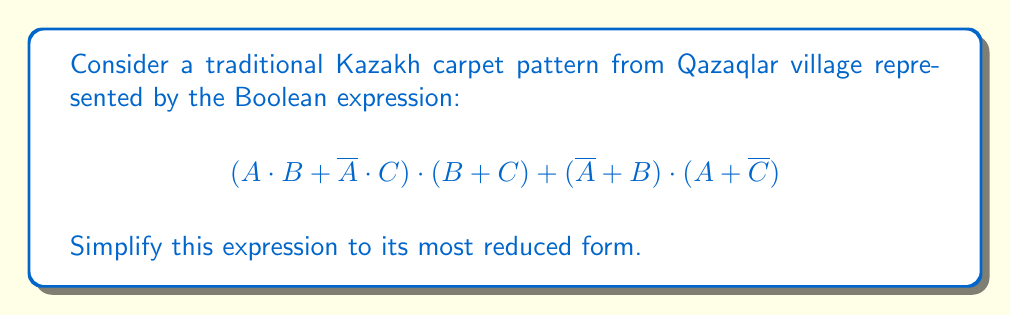Help me with this question. Let's simplify this expression step by step:

1) First, let's distribute the first term:
   $$(A \cdot B + \overline{A} \cdot C) \cdot (B + C) + (\overline{A} + B) \cdot (A + \overline{C})$$
   $$= A \cdot B \cdot B + A \cdot B \cdot C + \overline{A} \cdot C \cdot B + \overline{A} \cdot C \cdot C + (\overline{A} + B) \cdot (A + \overline{C})$$

2) Simplify using the idempotent law $(X \cdot X = X)$:
   $$= A \cdot B + A \cdot B \cdot C + \overline{A} \cdot C \cdot B + \overline{A} \cdot C + (\overline{A} + B) \cdot (A + \overline{C})$$

3) Distribute the last term:
   $$= A \cdot B + A \cdot B \cdot C + \overline{A} \cdot C \cdot B + \overline{A} \cdot C + \overline{A} \cdot A + \overline{A} \cdot \overline{C} + B \cdot A + B \cdot \overline{C}$$

4) Simplify using the complement law $(\overline{X} \cdot X = 0)$ and identity law $(X + 0 = X)$:
   $$= A \cdot B + A \cdot B \cdot C + \overline{A} \cdot C \cdot B + \overline{A} \cdot C + \overline{A} \cdot \overline{C} + B \cdot A + B \cdot \overline{C}$$

5) Use the absorption law $(X + X \cdot Y = X)$:
   $$= A \cdot B + \overline{A} \cdot C + \overline{A} \cdot C \cdot B + \overline{A} \cdot \overline{C} + B \cdot \overline{C}$$

6) Use the distributive law:
   $$= A \cdot B + \overline{A} \cdot C + \overline{A} \cdot (C \cdot B + \overline{C}) + B \cdot \overline{C}$$

7) Simplify using the complement law $(\overline{X} + X = 1)$:
   $$= A \cdot B + \overline{A} \cdot C + \overline{A} \cdot (C \cdot B + \overline{C}) + B \cdot \overline{C}$$
   $$= A \cdot B + \overline{A} + B \cdot \overline{C}$$

8) Use the distributive law again:
   $$= (A + \overline{A}) \cdot (B + \overline{C})$$

9) Apply the complement law one last time:
   $$= B + \overline{C}$$

This is the most simplified form of the original expression.
Answer: $B + \overline{C}$ 